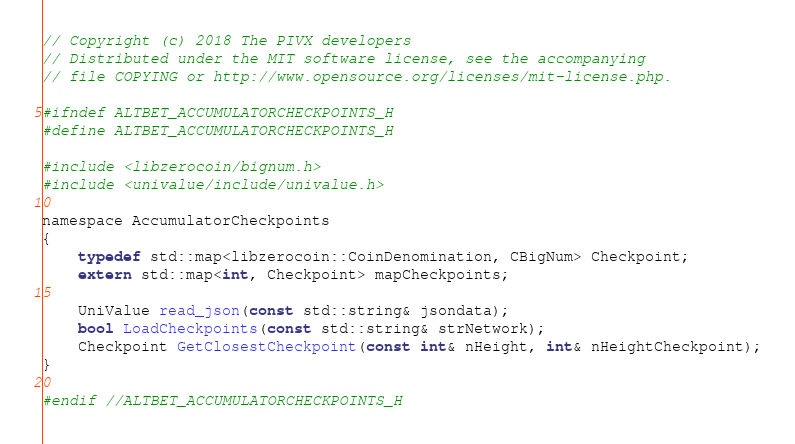<code> <loc_0><loc_0><loc_500><loc_500><_C_>// Copyright (c) 2018 The PIVX developers
// Distributed under the MIT software license, see the accompanying
// file COPYING or http://www.opensource.org/licenses/mit-license.php.

#ifndef ALTBET_ACCUMULATORCHECKPOINTS_H
#define ALTBET_ACCUMULATORCHECKPOINTS_H

#include <libzerocoin/bignum.h>
#include <univalue/include/univalue.h>

namespace AccumulatorCheckpoints
{
    typedef std::map<libzerocoin::CoinDenomination, CBigNum> Checkpoint;
    extern std::map<int, Checkpoint> mapCheckpoints;

    UniValue read_json(const std::string& jsondata);
    bool LoadCheckpoints(const std::string& strNetwork);
    Checkpoint GetClosestCheckpoint(const int& nHeight, int& nHeightCheckpoint);
}

#endif //ALTBET_ACCUMULATORCHECKPOINTS_H
</code> 